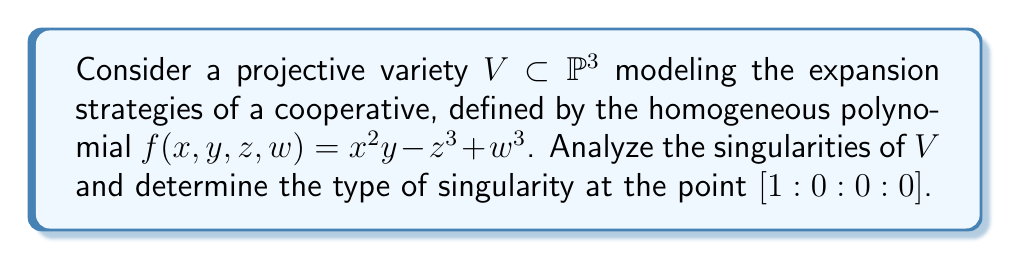Give your solution to this math problem. To analyze the singularities of the projective variety $V$, we need to follow these steps:

1) First, we need to find the partial derivatives of $f$ with respect to each variable:

   $\frac{\partial f}{\partial x} = 2xy$
   $\frac{\partial f}{\partial y} = x^2$
   $\frac{\partial f}{\partial z} = -3z^2$
   $\frac{\partial f}{\partial w} = 3w^2$

2) A point $[a:b:c:d]$ is singular if all partial derivatives vanish at that point. Let's evaluate these at $[1:0:0:0]$:

   $\frac{\partial f}{\partial x}(1,0,0,0) = 0$
   $\frac{\partial f}{\partial y}(1,0,0,0) = 1$
   $\frac{\partial f}{\partial z}(1,0,0,0) = 0$
   $\frac{\partial f}{\partial w}(1,0,0,0) = 0$

3) We see that not all partial derivatives vanish at $[1:0:0:0]$, as $\frac{\partial f}{\partial y} \neq 0$. Therefore, $[1:0:0:0]$ is not a singular point of $V$.

4) To find the actual singularities, we need to solve the system of equations:

   $2xy = 0$
   $x^2 = 0$
   $-3z^2 = 0$
   $3w^2 = 0$

5) This system is satisfied when $x = z = w = 0$, with $y$ arbitrary. In projective space, this corresponds to the point $[0:1:0:0]$.

6) To determine the type of singularity at $[0:1:0:0]$, we need to analyze the behavior of $f$ near this point. We can do this by considering the affine chart where $y \neq 0$, setting $y = 1$:

   $g(x,z,w) = f(x,1,z,w) = x^2 - z^3 + w^3$

7) The singularity at $[0:1:0:0]$ corresponds to the origin $(0,0,0)$ in this affine chart. We can see that this is an isolated singularity, as the quadratic term $x^2$ ensures that moving away from the origin in the $x$ direction immediately makes the variety smooth.

8) The singularity is of type $A_2$, also known as a cusp singularity, due to the presence of the $z^3$ term, which is the lowest-degree term in $z$ and $w$.
Answer: $[0:1:0:0]$ is an $A_2$ (cusp) singularity; $[1:0:0:0]$ is not singular. 